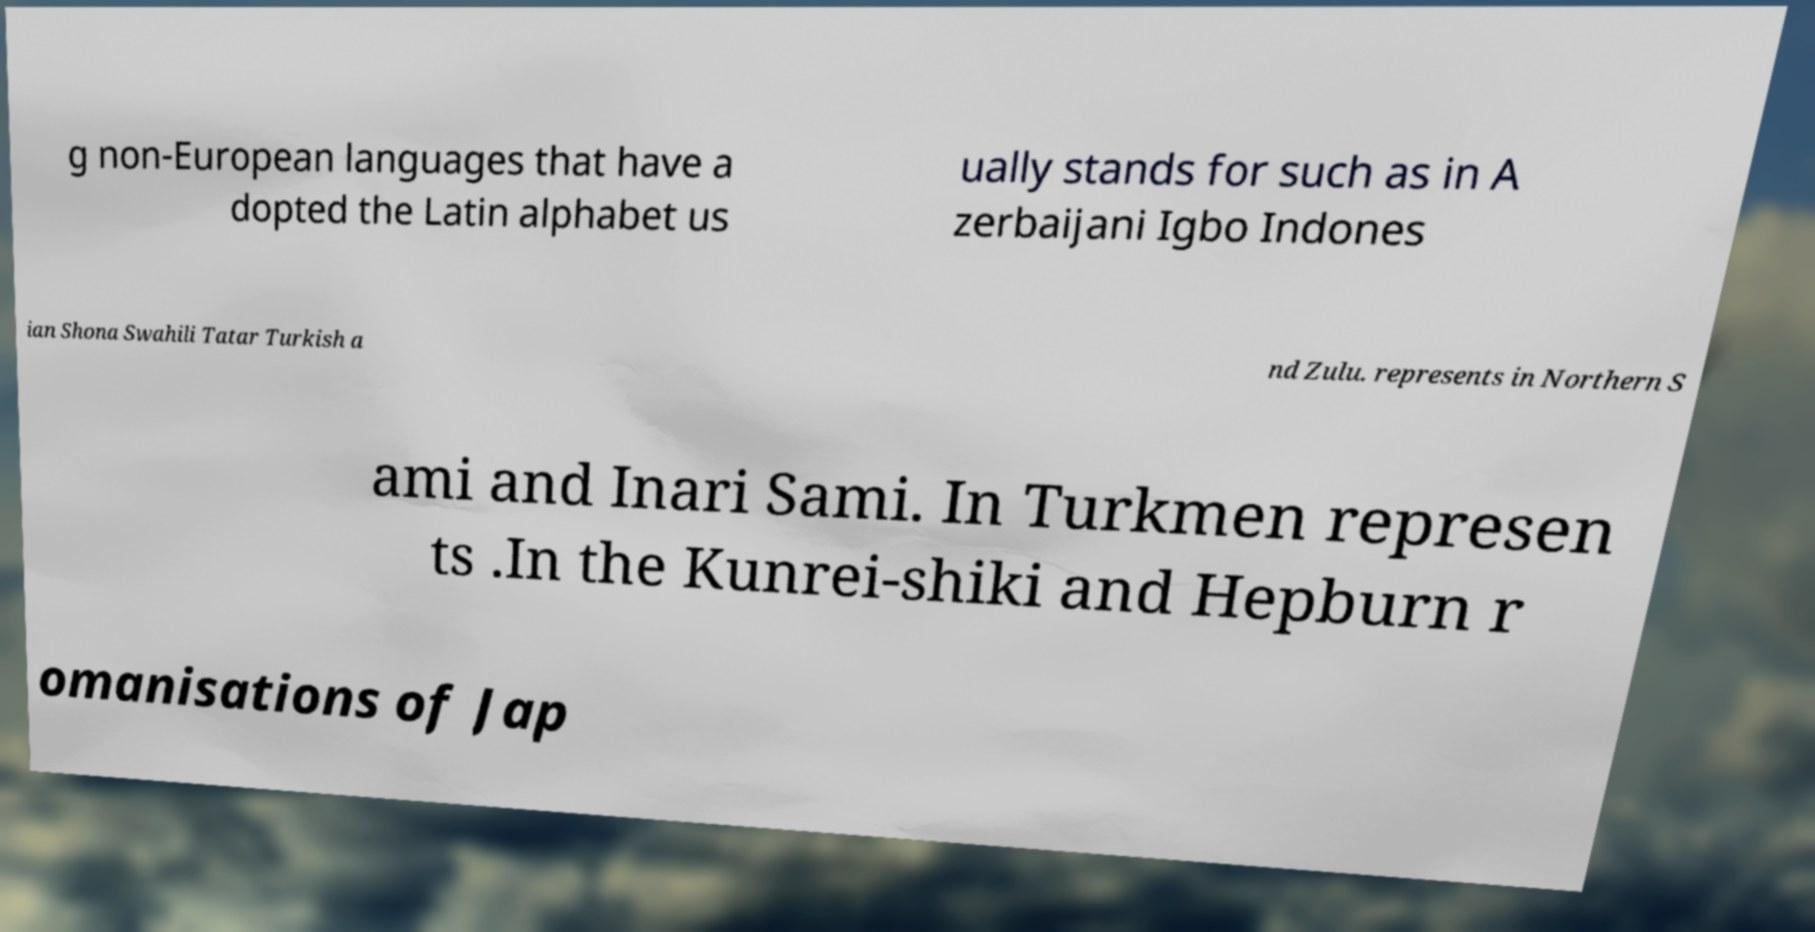What messages or text are displayed in this image? I need them in a readable, typed format. g non-European languages that have a dopted the Latin alphabet us ually stands for such as in A zerbaijani Igbo Indones ian Shona Swahili Tatar Turkish a nd Zulu. represents in Northern S ami and Inari Sami. In Turkmen represen ts .In the Kunrei-shiki and Hepburn r omanisations of Jap 